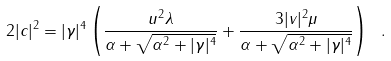<formula> <loc_0><loc_0><loc_500><loc_500>2 | c | ^ { 2 } = | \gamma | ^ { 4 } \left ( \frac { u ^ { 2 } \lambda } { \alpha + \sqrt { \alpha ^ { 2 } + | \gamma | ^ { 4 } } } + \frac { 3 | v | ^ { 2 } \mu } { \alpha + \sqrt { \alpha ^ { 2 } + | \gamma | ^ { 4 } } } \right ) \ .</formula> 